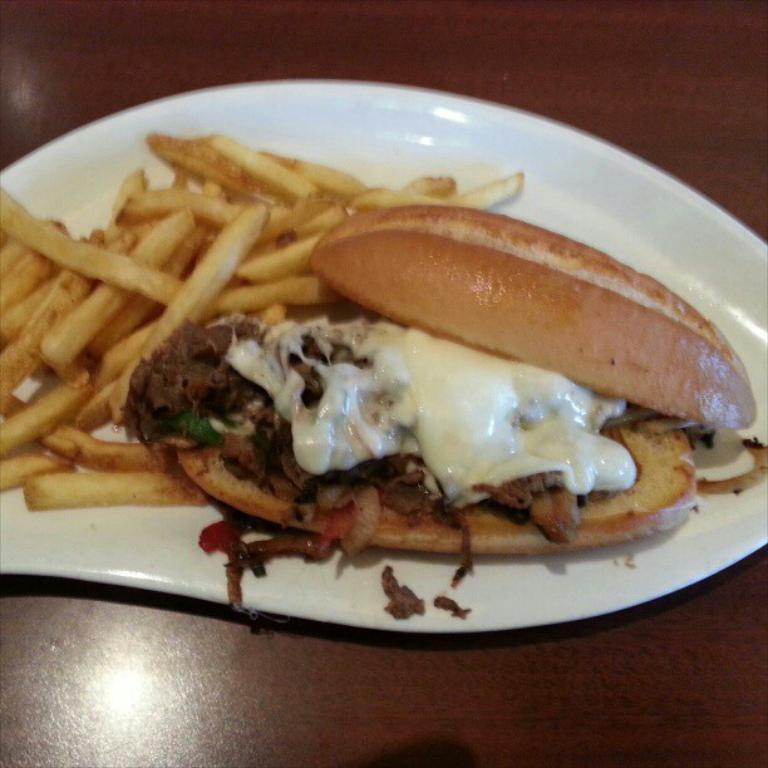In one or two sentences, can you explain what this image depicts? In this image there is a food item on the white color plate , which is on the wooden board. 